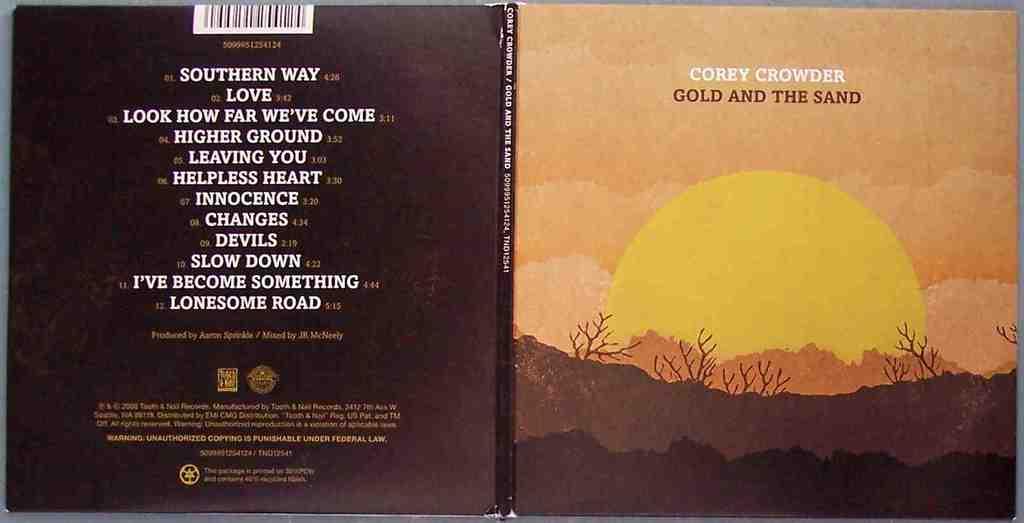What author wrote, "gold and the sand"?
Offer a terse response. Corey crowder. What is track 4?
Your answer should be very brief. Higher ground. 